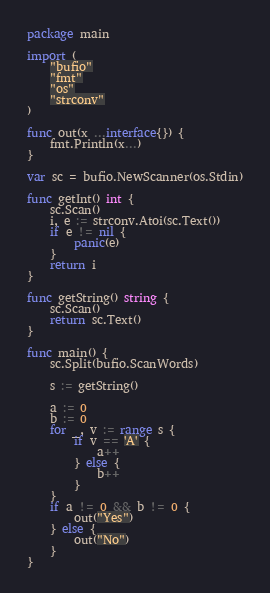Convert code to text. <code><loc_0><loc_0><loc_500><loc_500><_Go_>package main

import (
	"bufio"
	"fmt"
	"os"
	"strconv"
)

func out(x ...interface{}) {
	fmt.Println(x...)
}

var sc = bufio.NewScanner(os.Stdin)

func getInt() int {
	sc.Scan()
	i, e := strconv.Atoi(sc.Text())
	if e != nil {
		panic(e)
	}
	return i
}

func getString() string {
	sc.Scan()
	return sc.Text()
}

func main() {
	sc.Split(bufio.ScanWords)

	s := getString()

	a := 0
	b := 0
	for _, v := range s {
		if v == 'A' {
			a++
		} else {
			b++
		}
	}
	if a != 0 && b != 0 {
		out("Yes")
	} else {
		out("No")
	}
}
</code> 